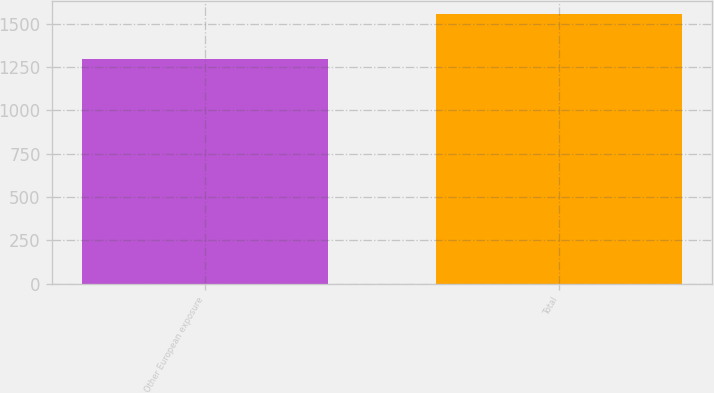Convert chart. <chart><loc_0><loc_0><loc_500><loc_500><bar_chart><fcel>Other European exposure<fcel>Total<nl><fcel>1299<fcel>1554<nl></chart> 